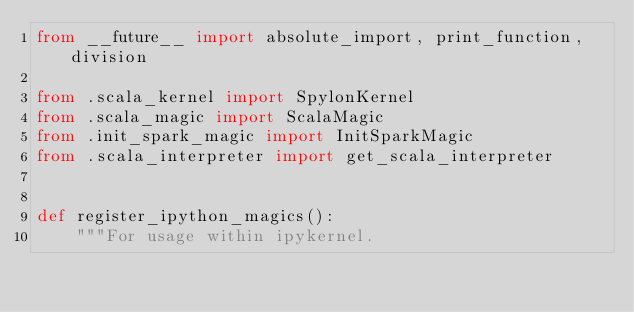<code> <loc_0><loc_0><loc_500><loc_500><_Python_>from __future__ import absolute_import, print_function, division

from .scala_kernel import SpylonKernel
from .scala_magic import ScalaMagic
from .init_spark_magic import InitSparkMagic
from .scala_interpreter import get_scala_interpreter


def register_ipython_magics():
    """For usage within ipykernel.
</code> 